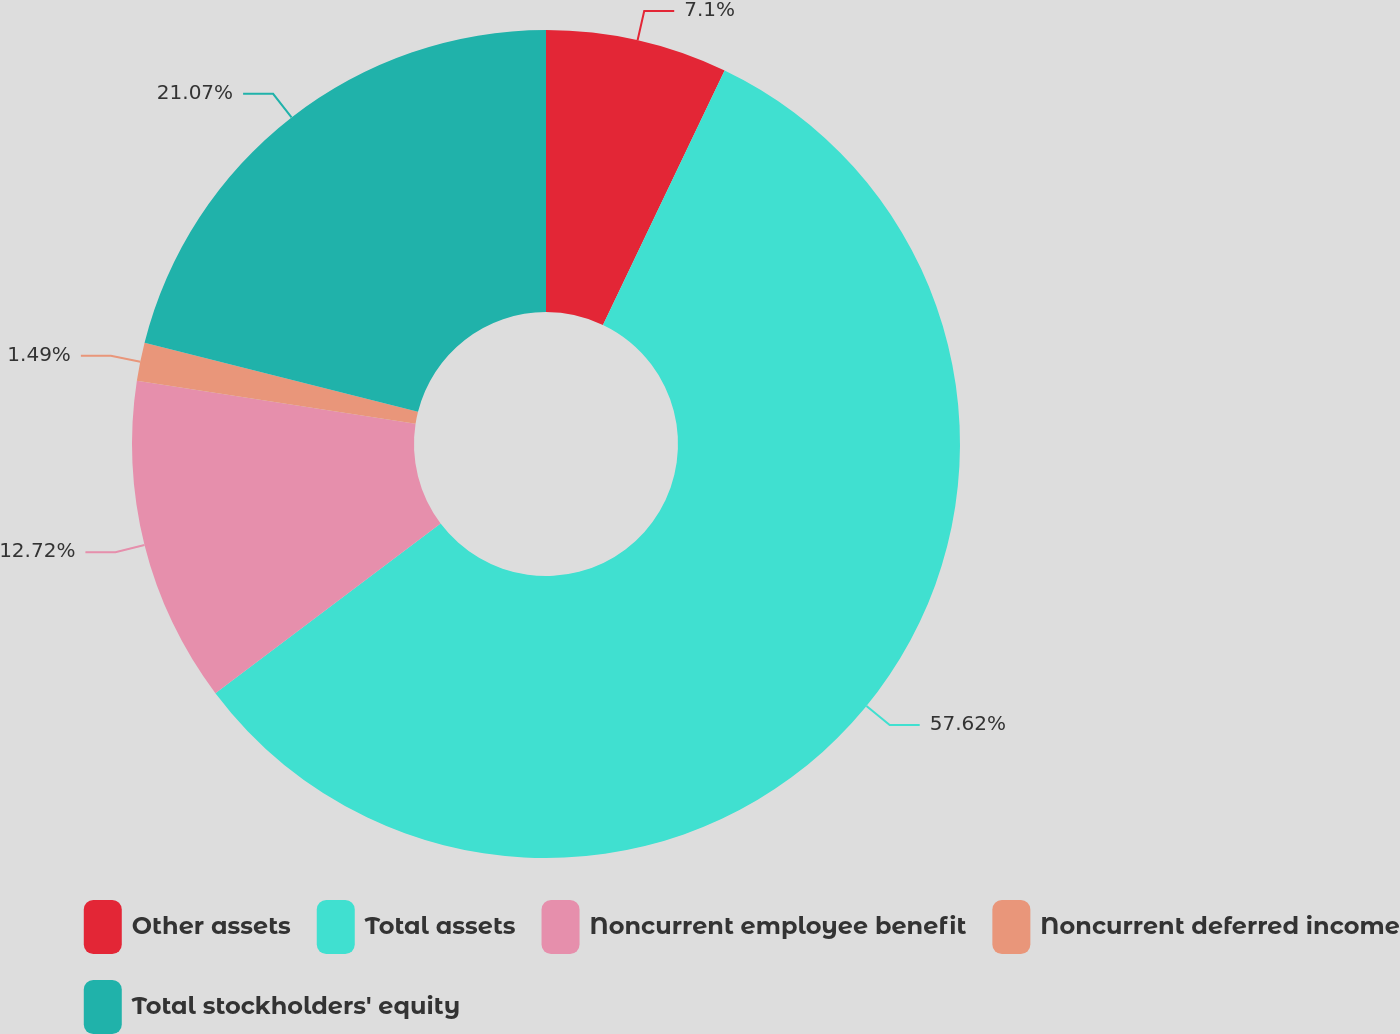Convert chart. <chart><loc_0><loc_0><loc_500><loc_500><pie_chart><fcel>Other assets<fcel>Total assets<fcel>Noncurrent employee benefit<fcel>Noncurrent deferred income<fcel>Total stockholders' equity<nl><fcel>7.1%<fcel>57.62%<fcel>12.72%<fcel>1.49%<fcel>21.07%<nl></chart> 